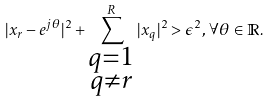<formula> <loc_0><loc_0><loc_500><loc_500>| x _ { r } - e ^ { j \theta } | ^ { 2 } + \sum _ { \substack { q = 1 \\ q \neq r } } ^ { R } | x _ { q } | ^ { 2 } > \epsilon ^ { 2 } , \, \forall \theta \in \mathbb { R } .</formula> 